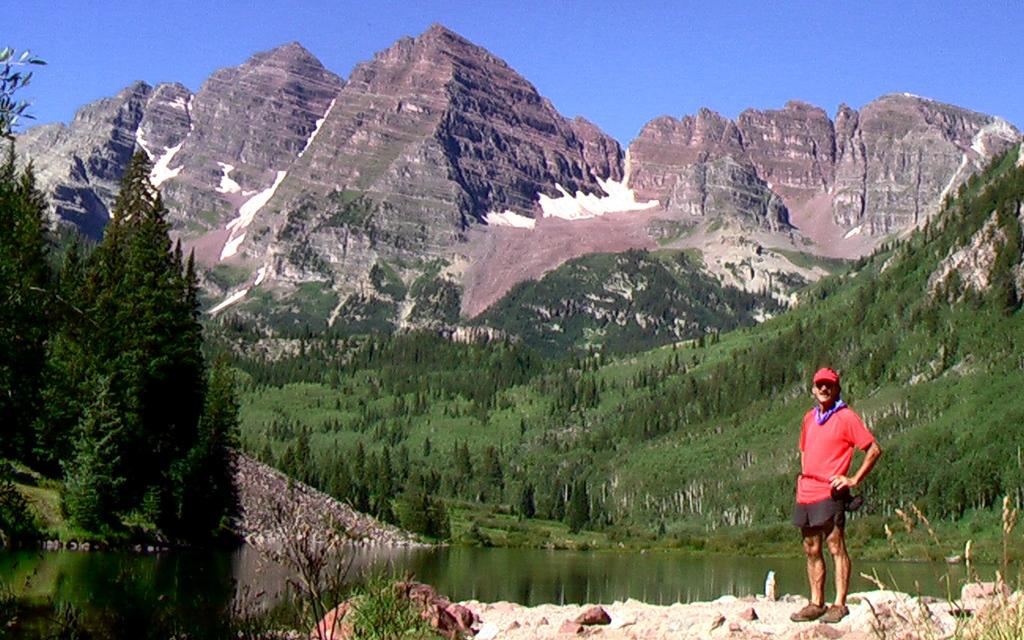What is the main subject of the image? There is a man standing in the image. What can be seen in the background of the image? The sky is visible in the background of the image, and its color is blue. What type of natural environment is depicted in the image? The image features water, grass, plants, trees, rocks, and hills, indicating a natural setting. What type of tomatoes can be seen growing on the stove in the image? There is no stove or tomatoes present in the image. What is the reason for the man standing in the image? The image does not provide any information about the man's reason for standing, so we cannot determine the reason from the image. 